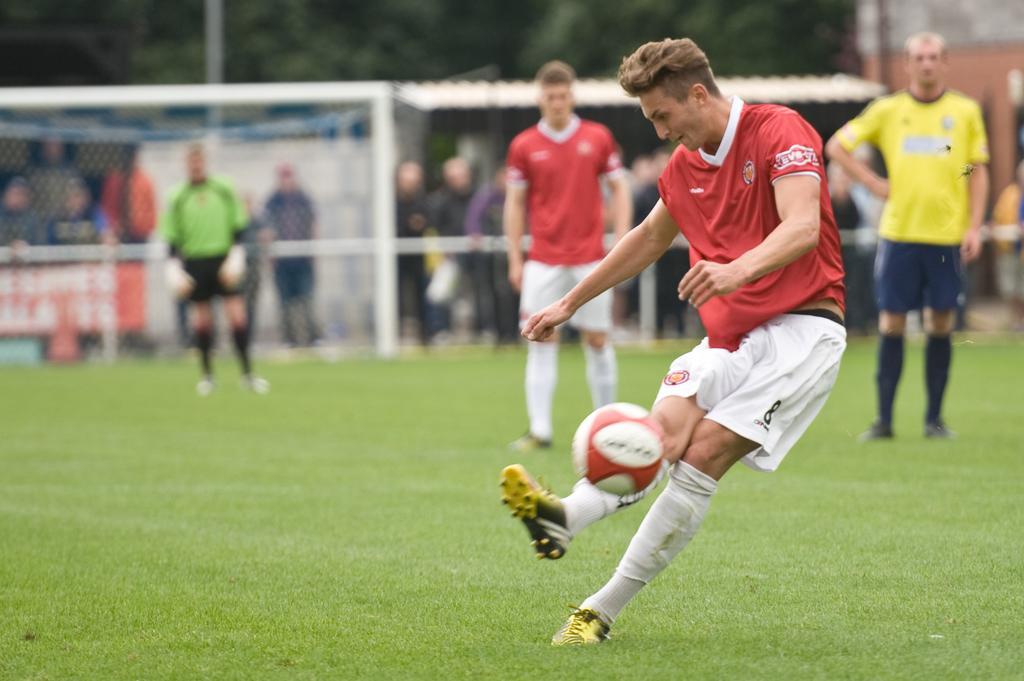Could you give a brief overview of what you see in this image? There are four men on the ground. The men with the red t-shirt is kicking the ball with his leg. At the back of him there are two men standing. A men to the left side is wearing a red t-shirt and the other man in the right side is wearing a yellow t-shirt. The man in the back side is wearing a green t-shirt is standing as a goalkeeper. In the background there are some people standing and on top of them there is a roof and there are some trees. 